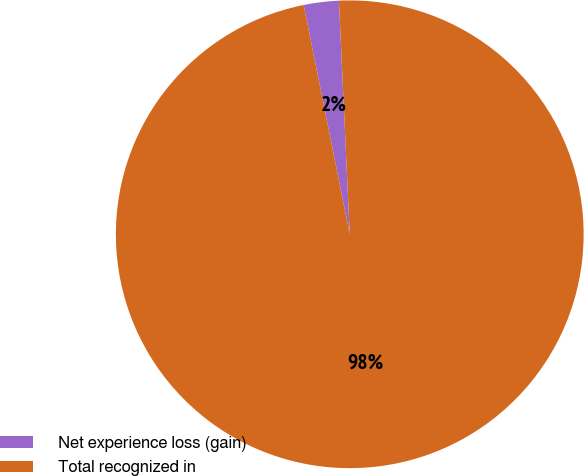Convert chart. <chart><loc_0><loc_0><loc_500><loc_500><pie_chart><fcel>Net experience loss (gain)<fcel>Total recognized in<nl><fcel>2.42%<fcel>97.58%<nl></chart> 